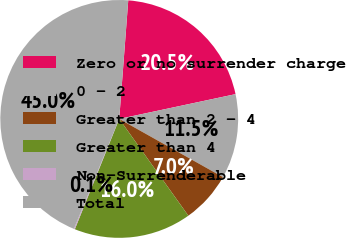<chart> <loc_0><loc_0><loc_500><loc_500><pie_chart><fcel>Zero or no surrender charge<fcel>0 - 2<fcel>Greater than 2 - 4<fcel>Greater than 4<fcel>Non-Surrenderable<fcel>Total<nl><fcel>20.45%<fcel>11.48%<fcel>6.99%<fcel>15.96%<fcel>0.13%<fcel>44.99%<nl></chart> 